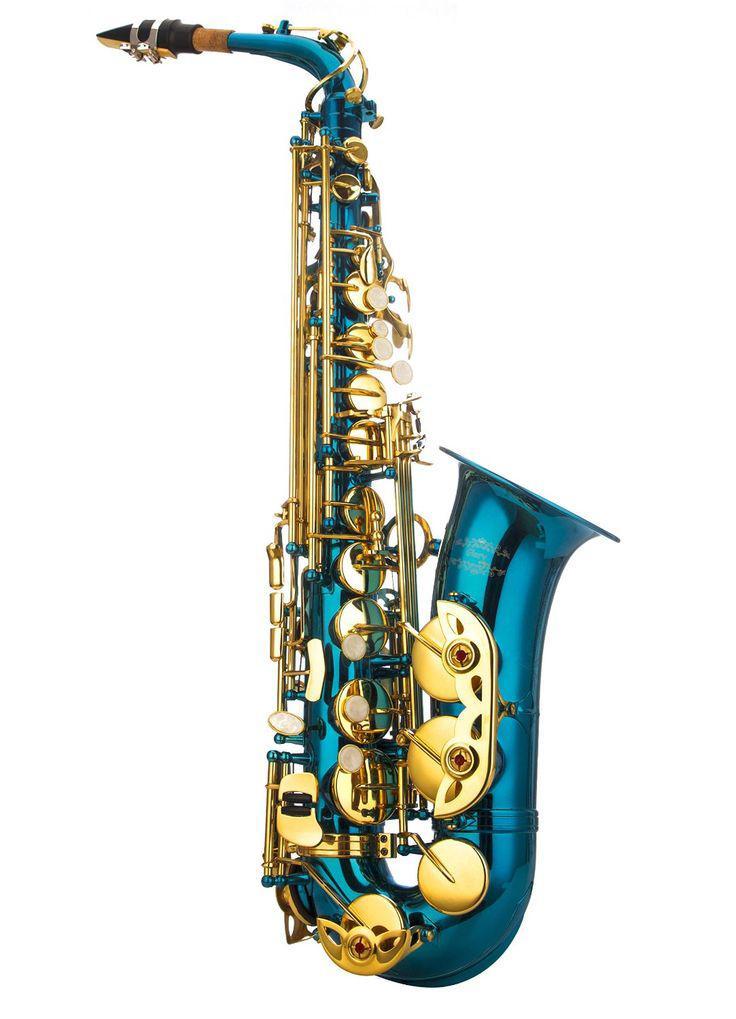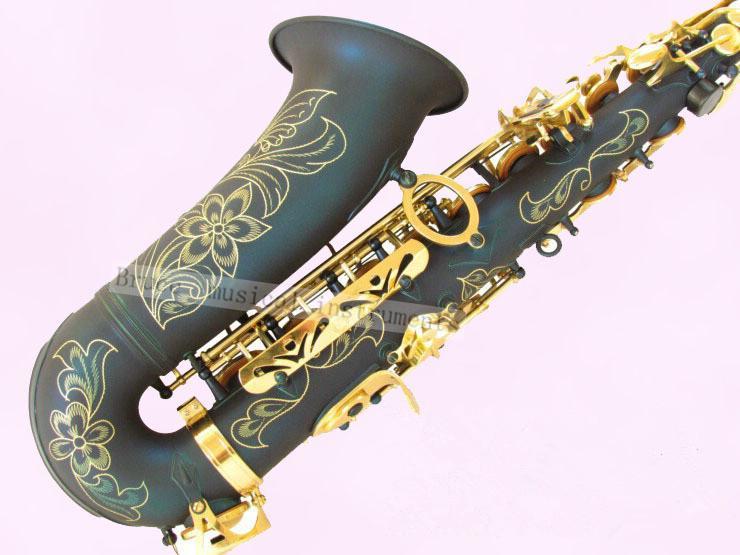The first image is the image on the left, the second image is the image on the right. For the images shown, is this caption "Each image has an instrument where the body is not gold, though all the buttons are." true? Answer yes or no. Yes. The first image is the image on the left, the second image is the image on the right. Given the left and right images, does the statement "The saxophone on the left is bright metallic blue with gold buttons and is posed with the bell facing rightward." hold true? Answer yes or no. Yes. 